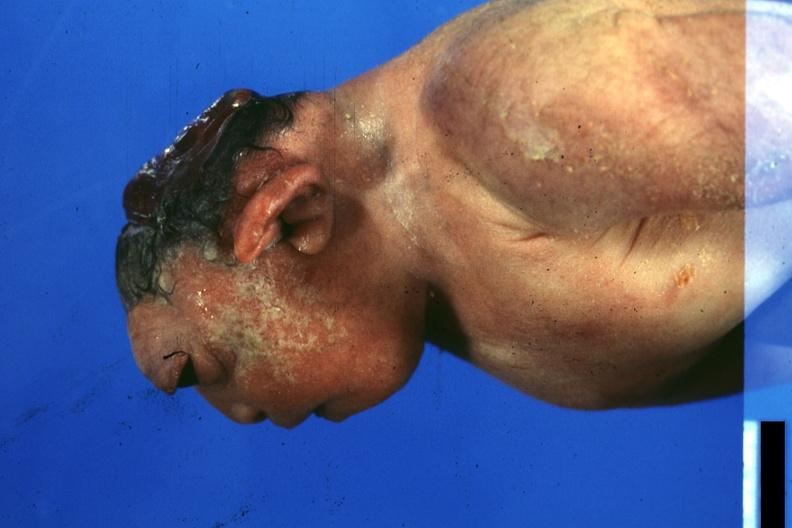what is present?
Answer the question using a single word or phrase. Anencephaly 